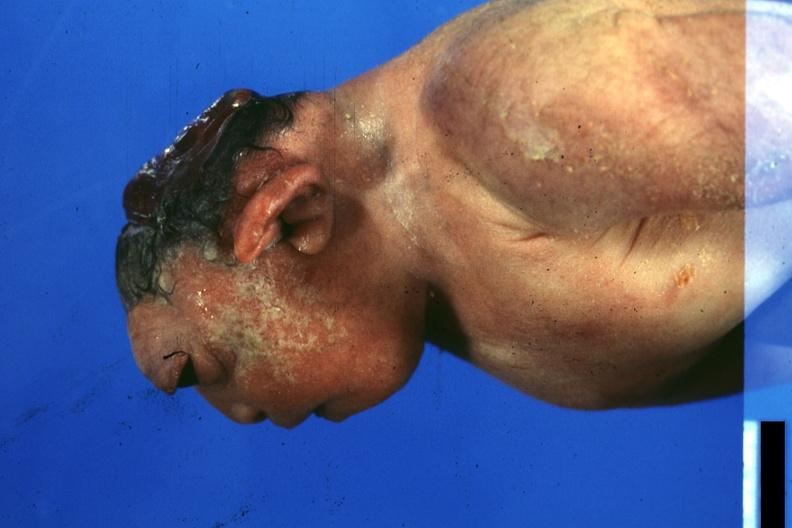what is present?
Answer the question using a single word or phrase. Anencephaly 